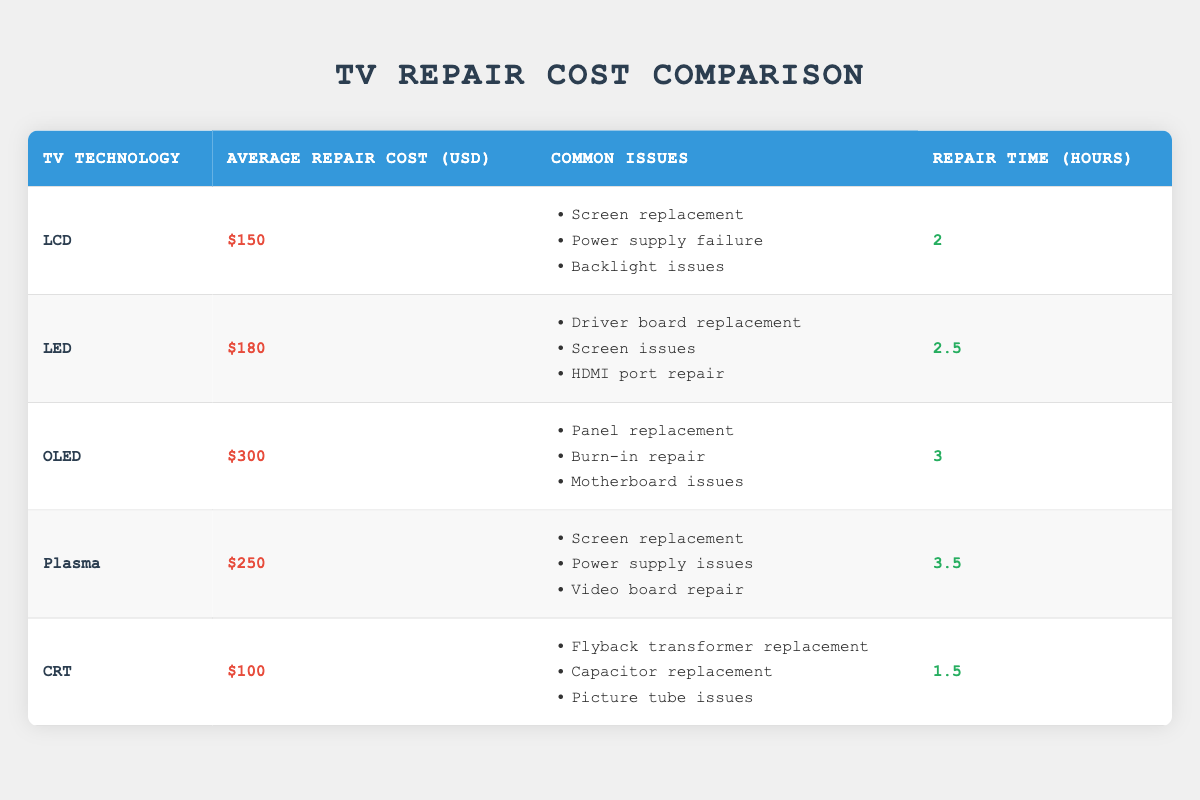What is the average repair cost for CRT TVs? The average repair cost for CRT TVs is listed directly in the table as $100.
Answer: 100 How many common issues are there for LED TVs? The table lists three common issues for LED TVs.
Answer: 3 Which TV technology has the highest average repair cost? The table indicates that OLED TVs have the highest average repair cost at $300.
Answer: OLED Is the repair time for plasma TVs less than 4 hours? The table shows that the repair time for plasma TVs is 3.5 hours, which is indeed less than 4 hours.
Answer: Yes What is the total average repair cost for OLED and Plasma TVs combined? To find the total average repair cost for OLED and Plasma TVs, sum their individual costs: OLED ($300) + Plasma ($250) = $550.
Answer: 550 Which TV technology has a common issue of "Burn-in repair"? The issue "Burn-in repair" is listed under the common issues for OLED TVs in the table.
Answer: OLED Is the average repair cost for LED TVs greater than that for LCD TVs? Looking at the table, the average repair cost for LED TVs is $180, which is greater than the $150 cost for LCD TVs.
Answer: Yes What is the average repair time for all TV technologies combined? First, add the repair times: LCD (2) + LED (2.5) + OLED (3) + Plasma (3.5) + CRT (1.5) = 12.5 hours. There are 5 TV technologies, so the average repair time is 12.5/5 = 2.5 hours.
Answer: 2.5 How many common issues does OLED share with Plasma TVs? The common issues for OLED (Panel replacement, Burn-in repair, Motherboard issues) and Plasma (Screen replacement, Power supply issues, Video board repair) are distinct; therefore, they share zero common issues.
Answer: 0 